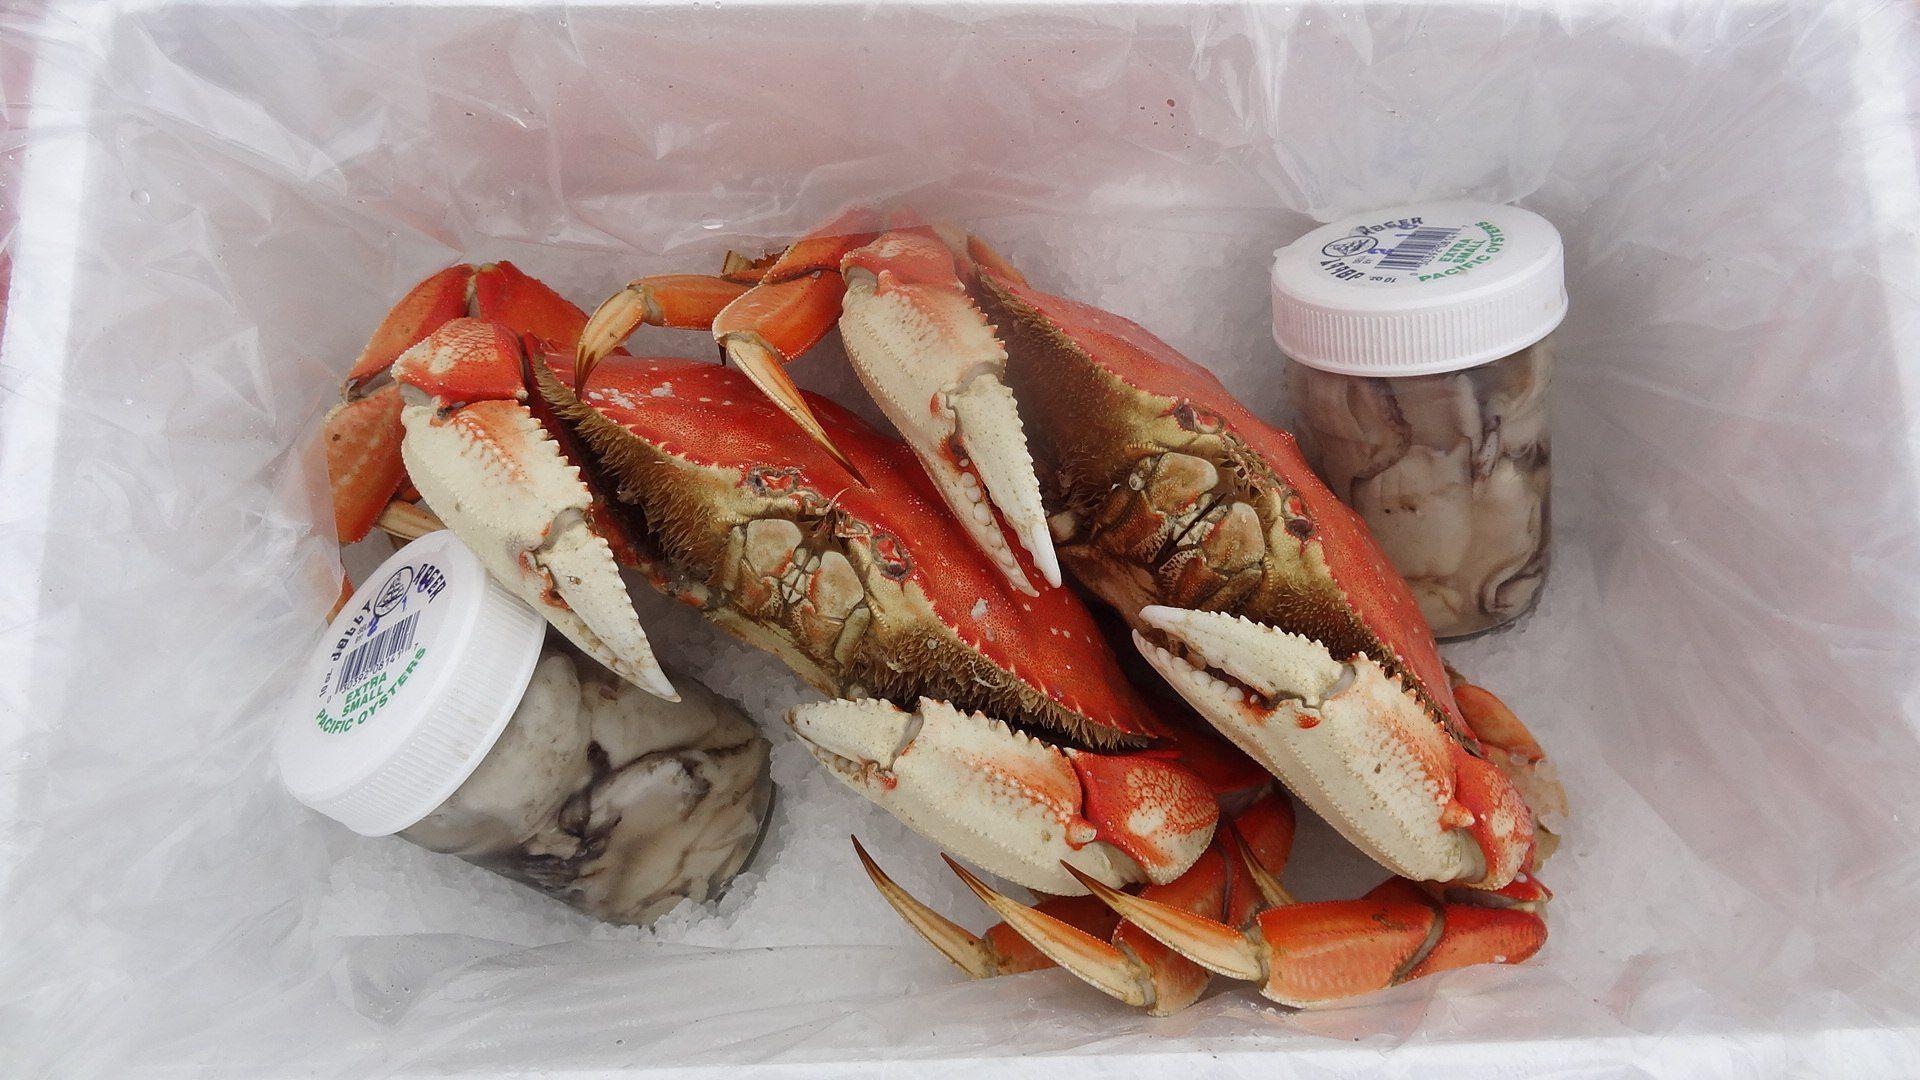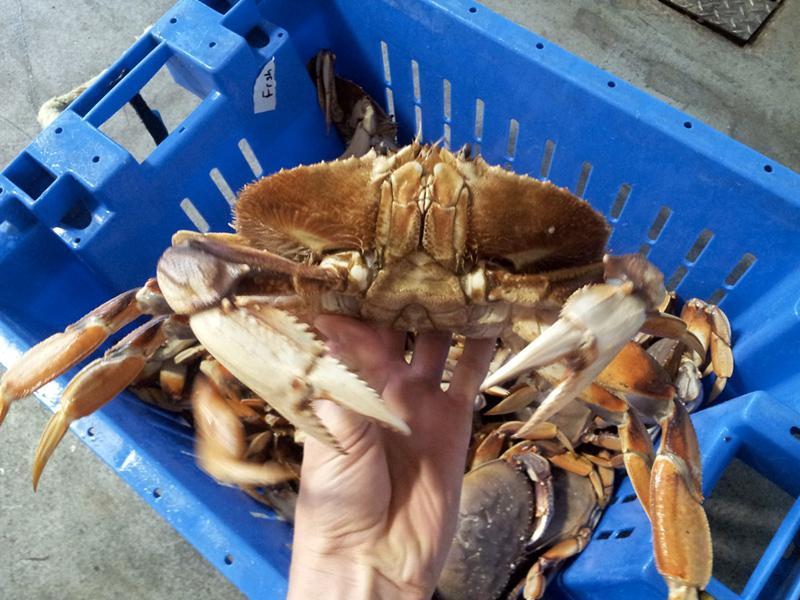The first image is the image on the left, the second image is the image on the right. For the images displayed, is the sentence "There are two small white top bottles on either side of two red crabs." factually correct? Answer yes or no. Yes. The first image is the image on the left, the second image is the image on the right. Analyze the images presented: Is the assertion "A hand is holding up a crab with its face and front claws turned toward the camera in the right image." valid? Answer yes or no. Yes. 